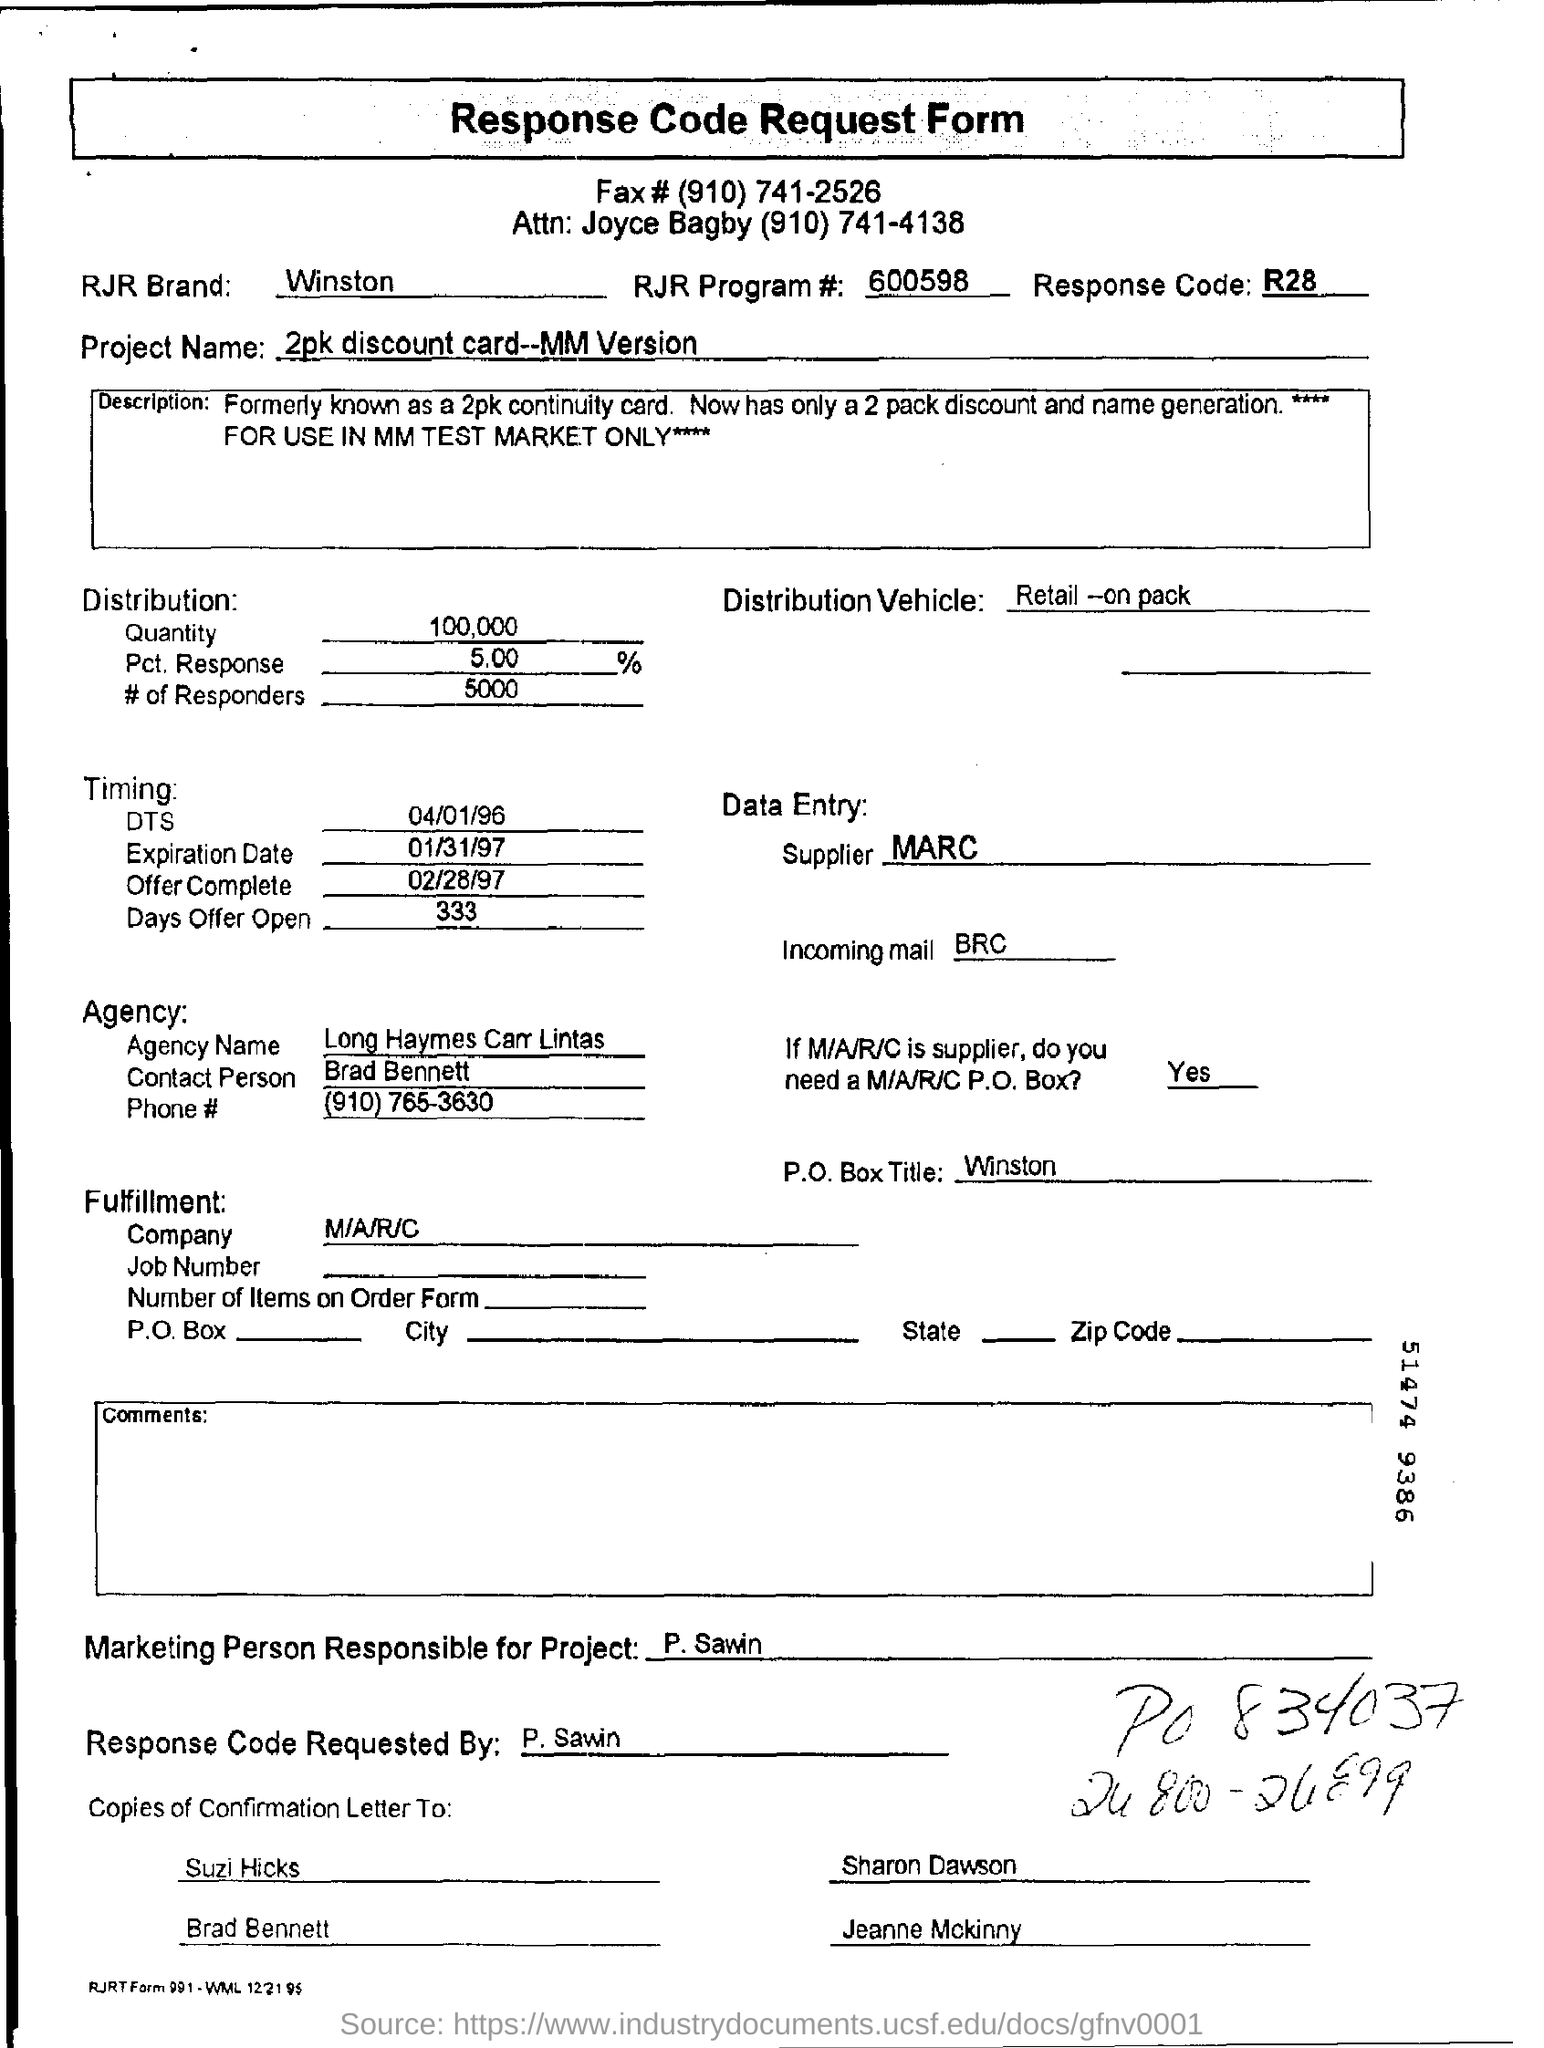Identify some key points in this picture. The P.O. Box title is Winston. The supplier is MARC. The response code mentioned in the form is R28. The RJR Brand, commonly associated with Winston cigarettes, is a well-known brand in the tobacco industry. The Response Code was requested by P. Sawin. 